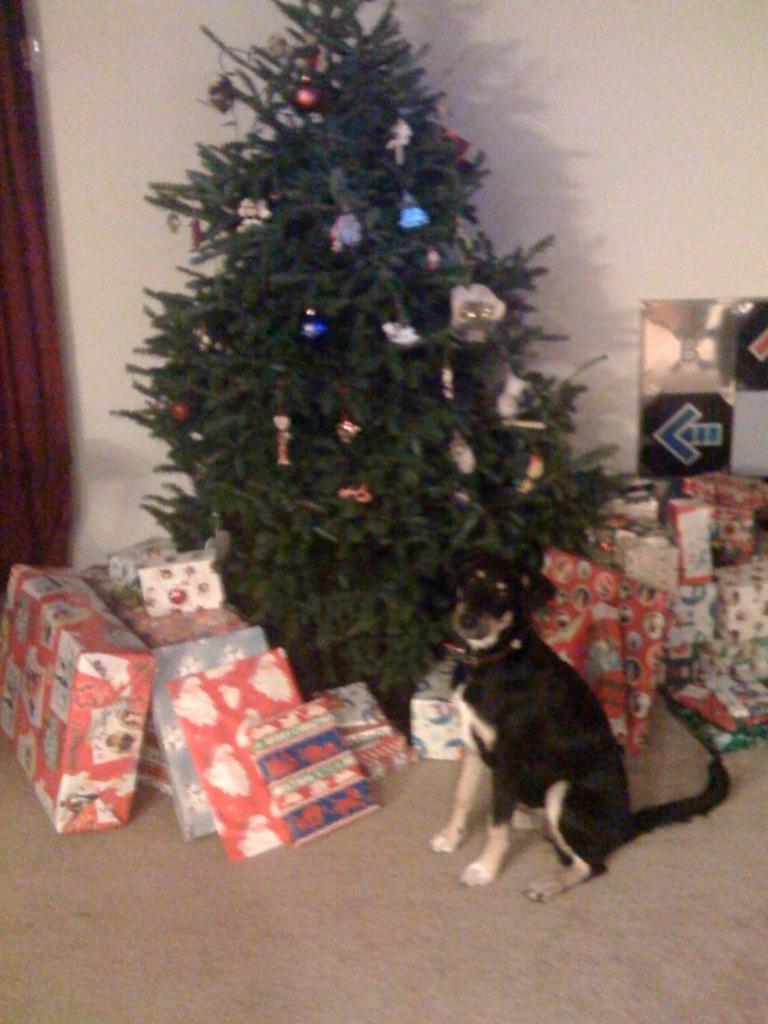In one or two sentences, can you explain what this image depicts? In this picture we can see a dog, gift boxes and a Christmas tree with some objects on it and in the background we can see wall. 